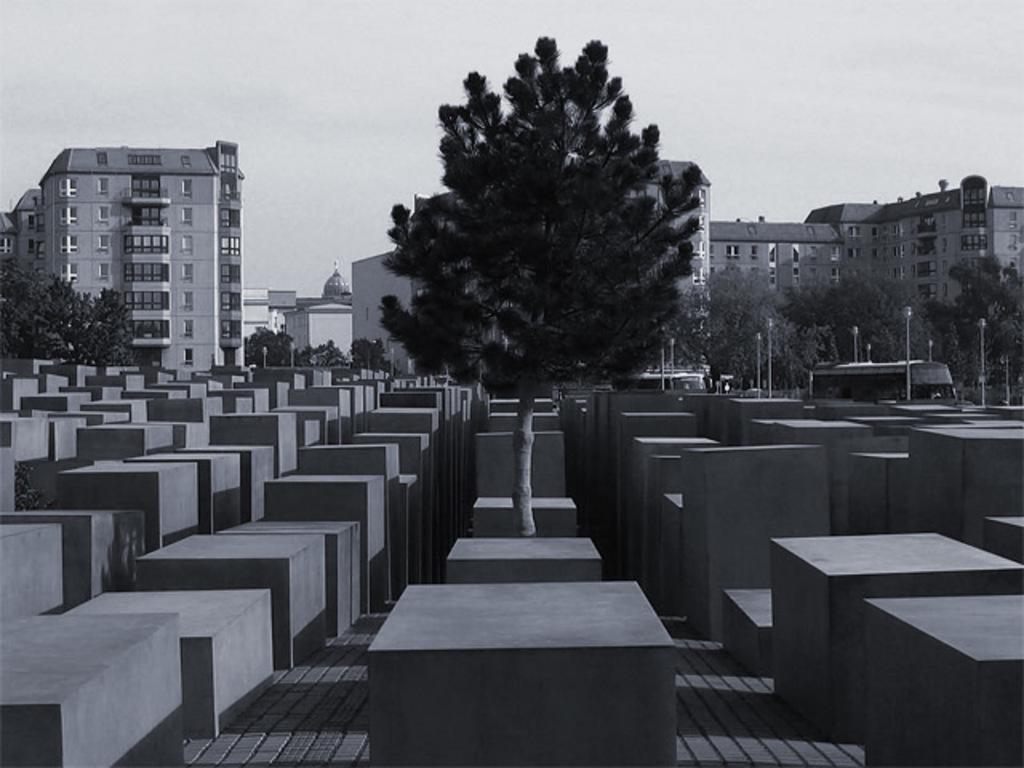Could you give a brief overview of what you see in this image? In the picture we can see boxes with different sizes in the path and in the middle of it, we can see a tree and in the background, we can see some trees, poles, and buildings with windows and glasses in it and behind it we can see a sky with clouds. 